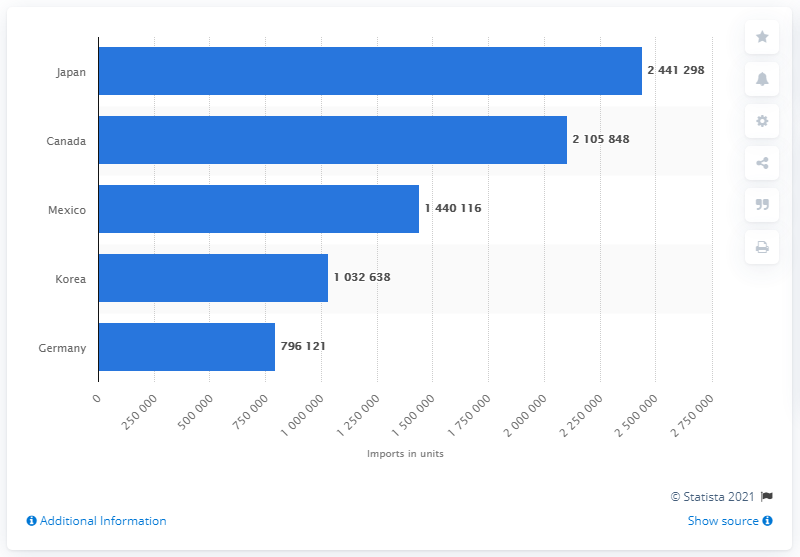Specify some key components in this picture. In 2012, a total of 1,032,638 passenger vehicles were imported from Korea. 